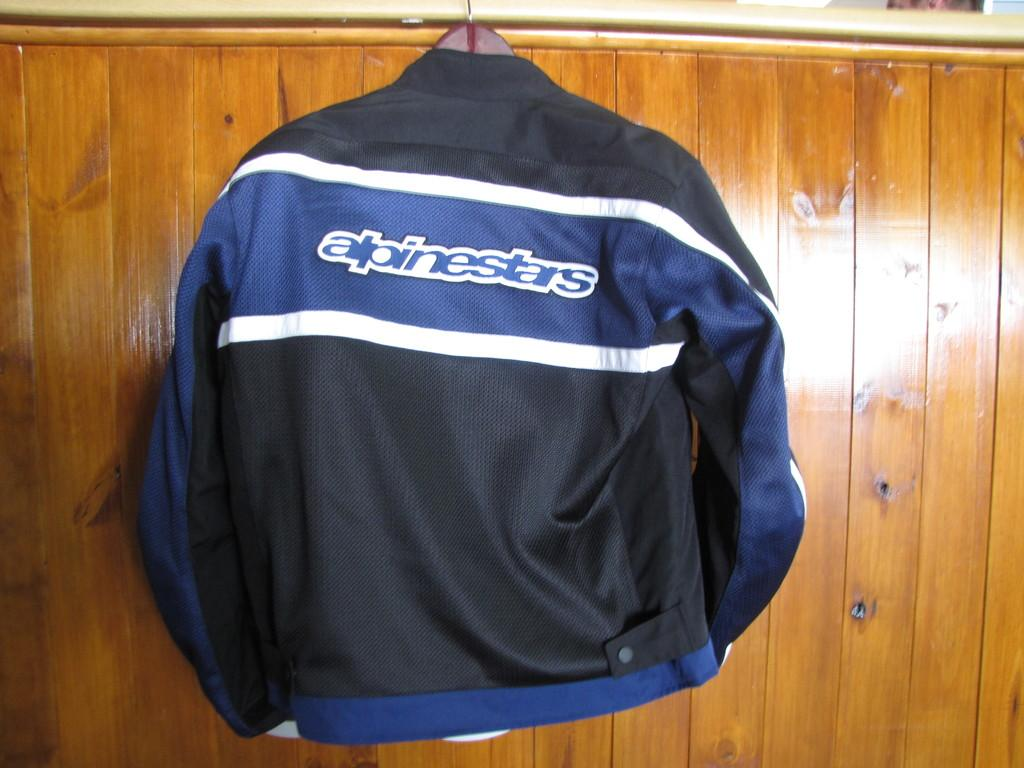<image>
Describe the image concisely. Alpinestars is displayed on the back of this jacket. 